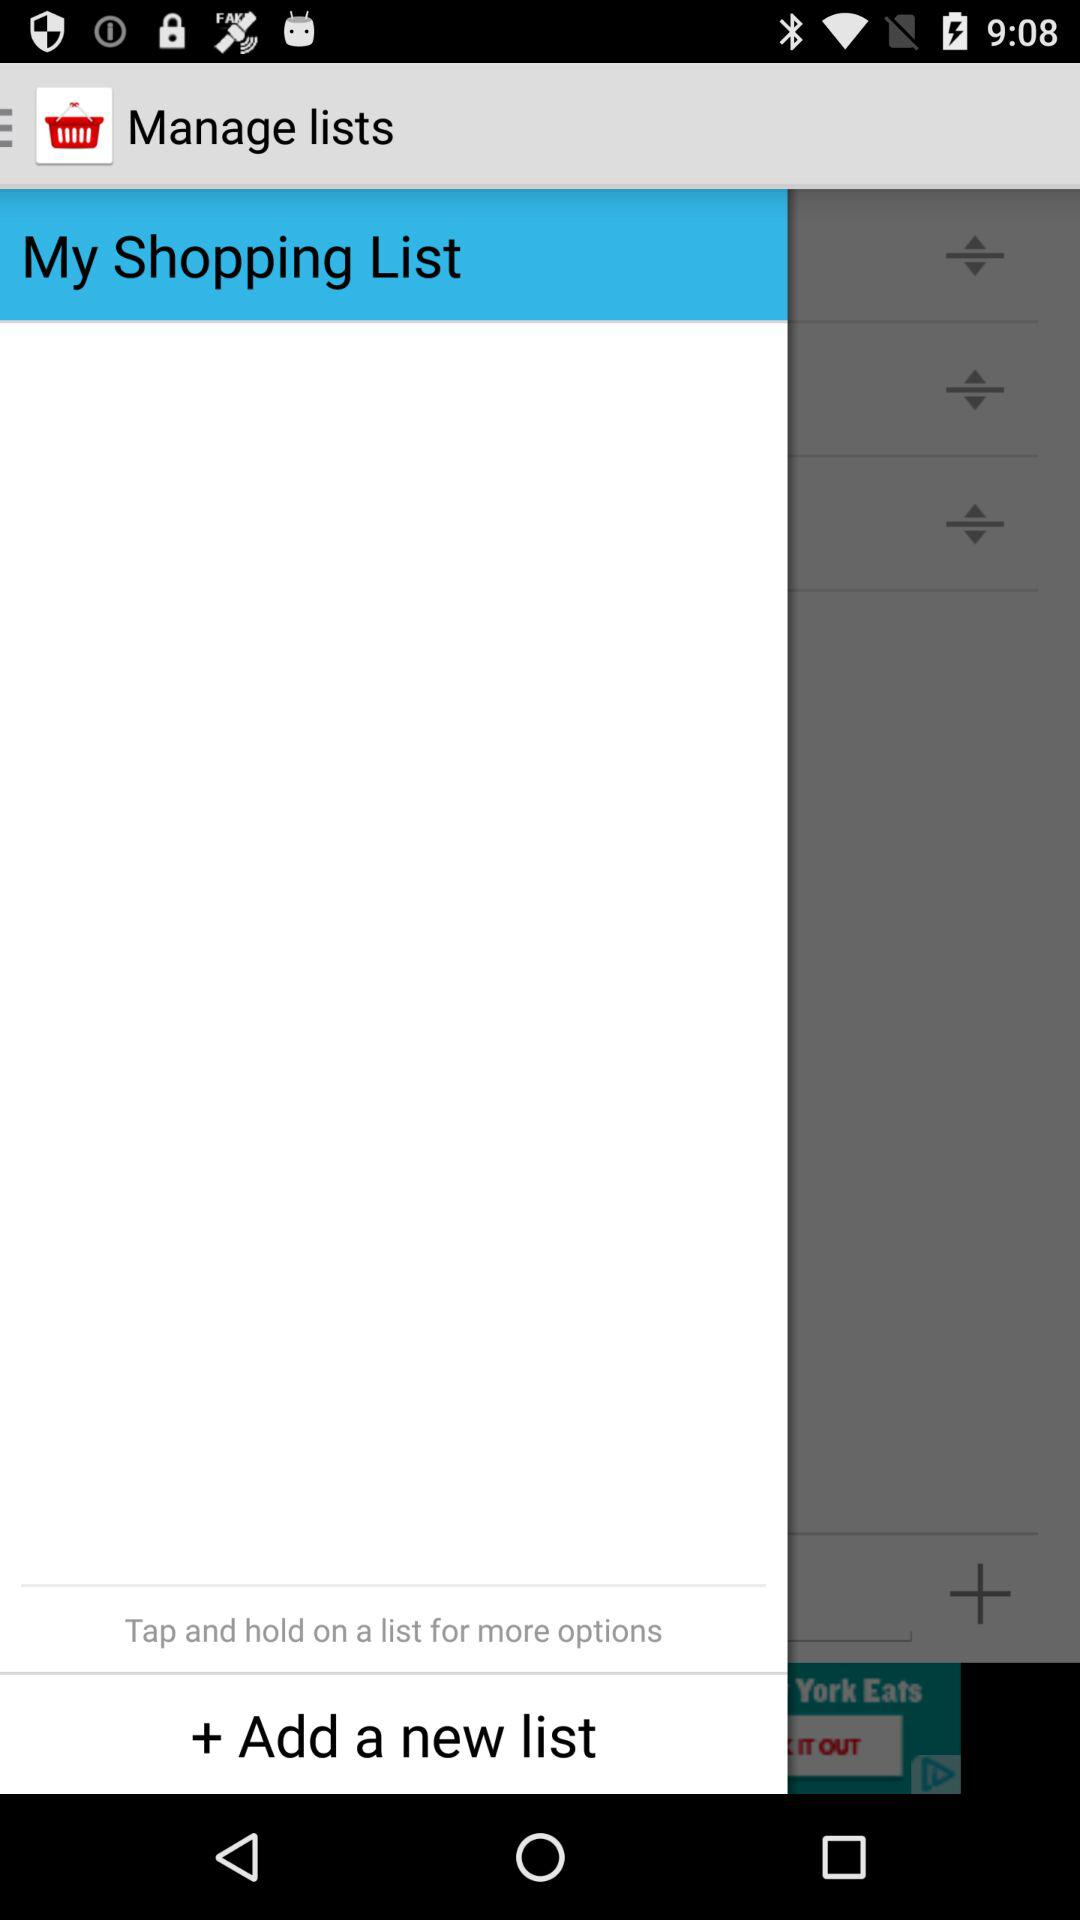What is the application name? The application name is "Shopping List". 